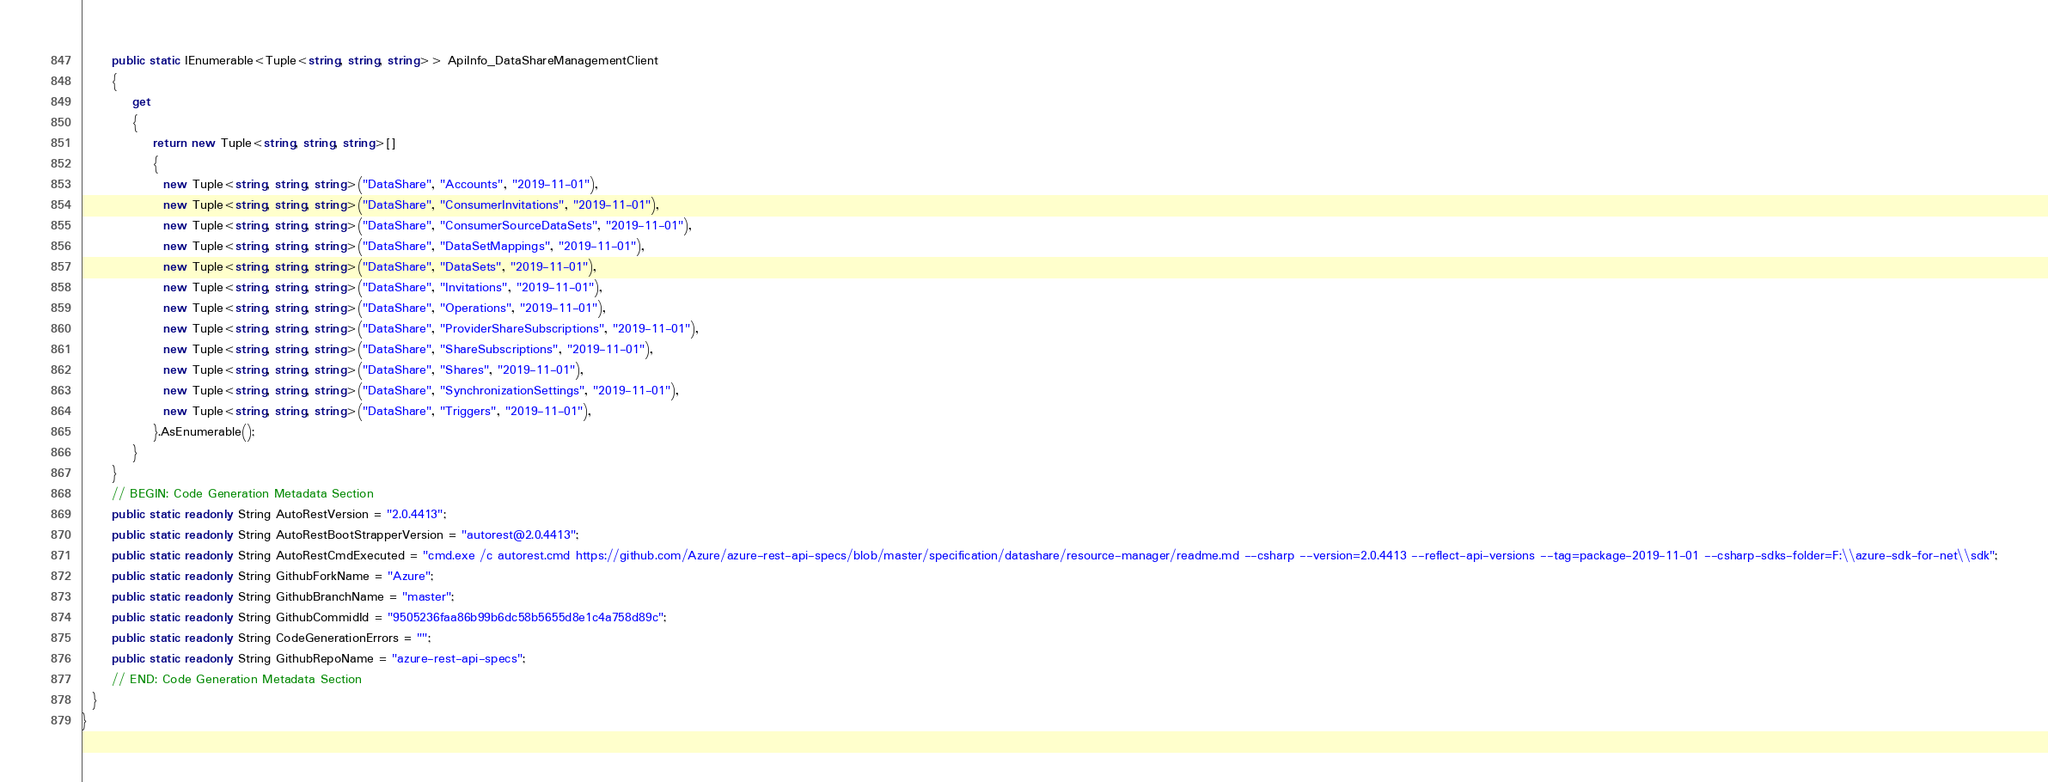Convert code to text. <code><loc_0><loc_0><loc_500><loc_500><_C#_>      public static IEnumerable<Tuple<string, string, string>> ApiInfo_DataShareManagementClient
      {
          get
          {
              return new Tuple<string, string, string>[]
              {
                new Tuple<string, string, string>("DataShare", "Accounts", "2019-11-01"),
                new Tuple<string, string, string>("DataShare", "ConsumerInvitations", "2019-11-01"),
                new Tuple<string, string, string>("DataShare", "ConsumerSourceDataSets", "2019-11-01"),
                new Tuple<string, string, string>("DataShare", "DataSetMappings", "2019-11-01"),
                new Tuple<string, string, string>("DataShare", "DataSets", "2019-11-01"),
                new Tuple<string, string, string>("DataShare", "Invitations", "2019-11-01"),
                new Tuple<string, string, string>("DataShare", "Operations", "2019-11-01"),
                new Tuple<string, string, string>("DataShare", "ProviderShareSubscriptions", "2019-11-01"),
                new Tuple<string, string, string>("DataShare", "ShareSubscriptions", "2019-11-01"),
                new Tuple<string, string, string>("DataShare", "Shares", "2019-11-01"),
                new Tuple<string, string, string>("DataShare", "SynchronizationSettings", "2019-11-01"),
                new Tuple<string, string, string>("DataShare", "Triggers", "2019-11-01"),
              }.AsEnumerable();
          }
      }
      // BEGIN: Code Generation Metadata Section
      public static readonly String AutoRestVersion = "2.0.4413";
      public static readonly String AutoRestBootStrapperVersion = "autorest@2.0.4413";
      public static readonly String AutoRestCmdExecuted = "cmd.exe /c autorest.cmd https://github.com/Azure/azure-rest-api-specs/blob/master/specification/datashare/resource-manager/readme.md --csharp --version=2.0.4413 --reflect-api-versions --tag=package-2019-11-01 --csharp-sdks-folder=F:\\azure-sdk-for-net\\sdk";
      public static readonly String GithubForkName = "Azure";
      public static readonly String GithubBranchName = "master";
      public static readonly String GithubCommidId = "9505236faa86b99b6dc58b5655d8e1c4a758d89c";
      public static readonly String CodeGenerationErrors = "";
      public static readonly String GithubRepoName = "azure-rest-api-specs";
      // END: Code Generation Metadata Section
  }
}

</code> 